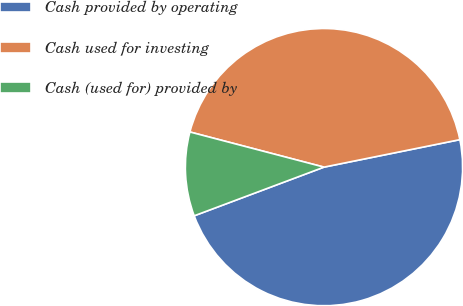Convert chart to OTSL. <chart><loc_0><loc_0><loc_500><loc_500><pie_chart><fcel>Cash provided by operating<fcel>Cash used for investing<fcel>Cash (used for) provided by<nl><fcel>47.46%<fcel>42.74%<fcel>9.79%<nl></chart> 